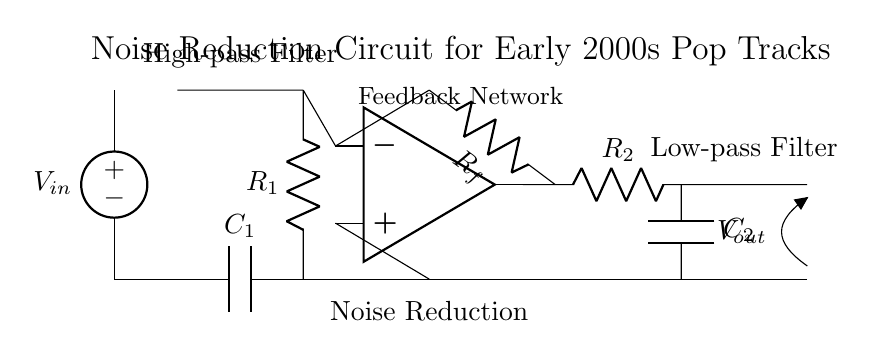What is the input voltage labeled as? The input voltage in the circuit is labeled as V_in, which indicates the source voltage that feeds into the circuit.
Answer: V_in What components are used in the high-pass filter? The high-pass filter consists of a capacitor labeled C1 and a resistor labeled R1, which work together to allow high-frequency signals to pass while attenuating lower frequencies.
Answer: C1, R1 What is the purpose of the op-amp in this circuit? The op-amp, positioned for noise reduction, amplifies (or reduces) the noise present in the audio signal, helping improve the overall sound quality by applying a feedback loop.
Answer: Noise reduction What type of filter follows the op-amp? The circuit includes a low-pass filter after the op-amp, which consists of a resistor R2 and a capacitor C2, allowing low-frequency signals to pass and filtering out higher frequencies.
Answer: Low-pass filter How many feedback components are in the circuit? There is one feedback component in the circuit, which is the resistor labeled R_f that connects from the output of the op-amp back to its inverting input, forming a negative feedback loop.
Answer: One What role does the capacitor C2 play in the circuit? The capacitor C2 in the low-pass filter helps smooth out fluctuations and reduces high-frequency noise from the audio signal, thereby improving audio clarity and quality.
Answer: Reduces high-frequency noise What overall function does this noise reduction circuit serve? The overall function of this noise reduction circuit is to filter unwanted noise from audio signals, especially beneficial in enhancing the quality of digitized early 2000s pop tracks by allowing desirable frequencies to pass while attenuating the rest.
Answer: Improve audio quality 